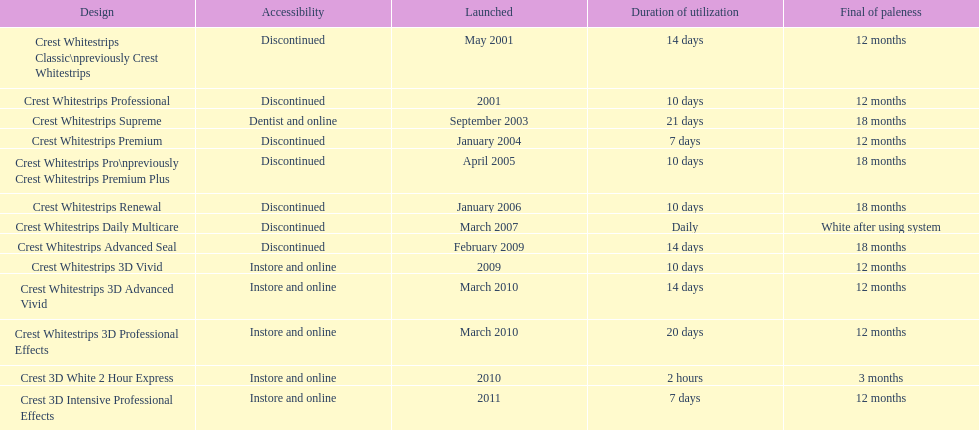What is the number of products that were introduced in 2010? 3. 